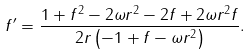Convert formula to latex. <formula><loc_0><loc_0><loc_500><loc_500>f ^ { \prime } = \frac { 1 + f ^ { 2 } - 2 \omega r ^ { 2 } - 2 f + 2 \omega r ^ { 2 } f } { 2 r \left ( - 1 + f - \omega r ^ { 2 } \right ) } .</formula> 